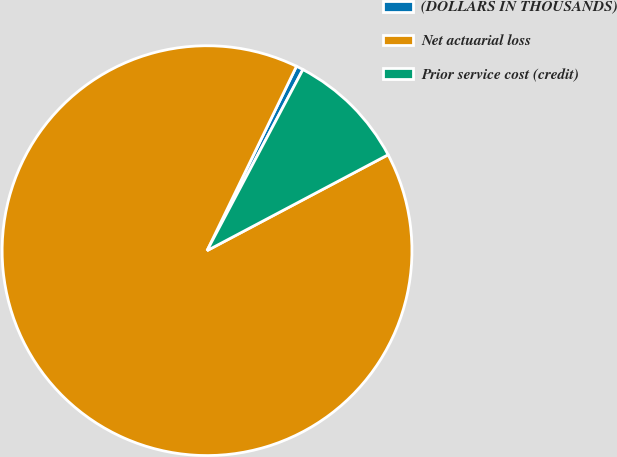<chart> <loc_0><loc_0><loc_500><loc_500><pie_chart><fcel>(DOLLARS IN THOUSANDS)<fcel>Net actuarial loss<fcel>Prior service cost (credit)<nl><fcel>0.56%<fcel>89.94%<fcel>9.5%<nl></chart> 